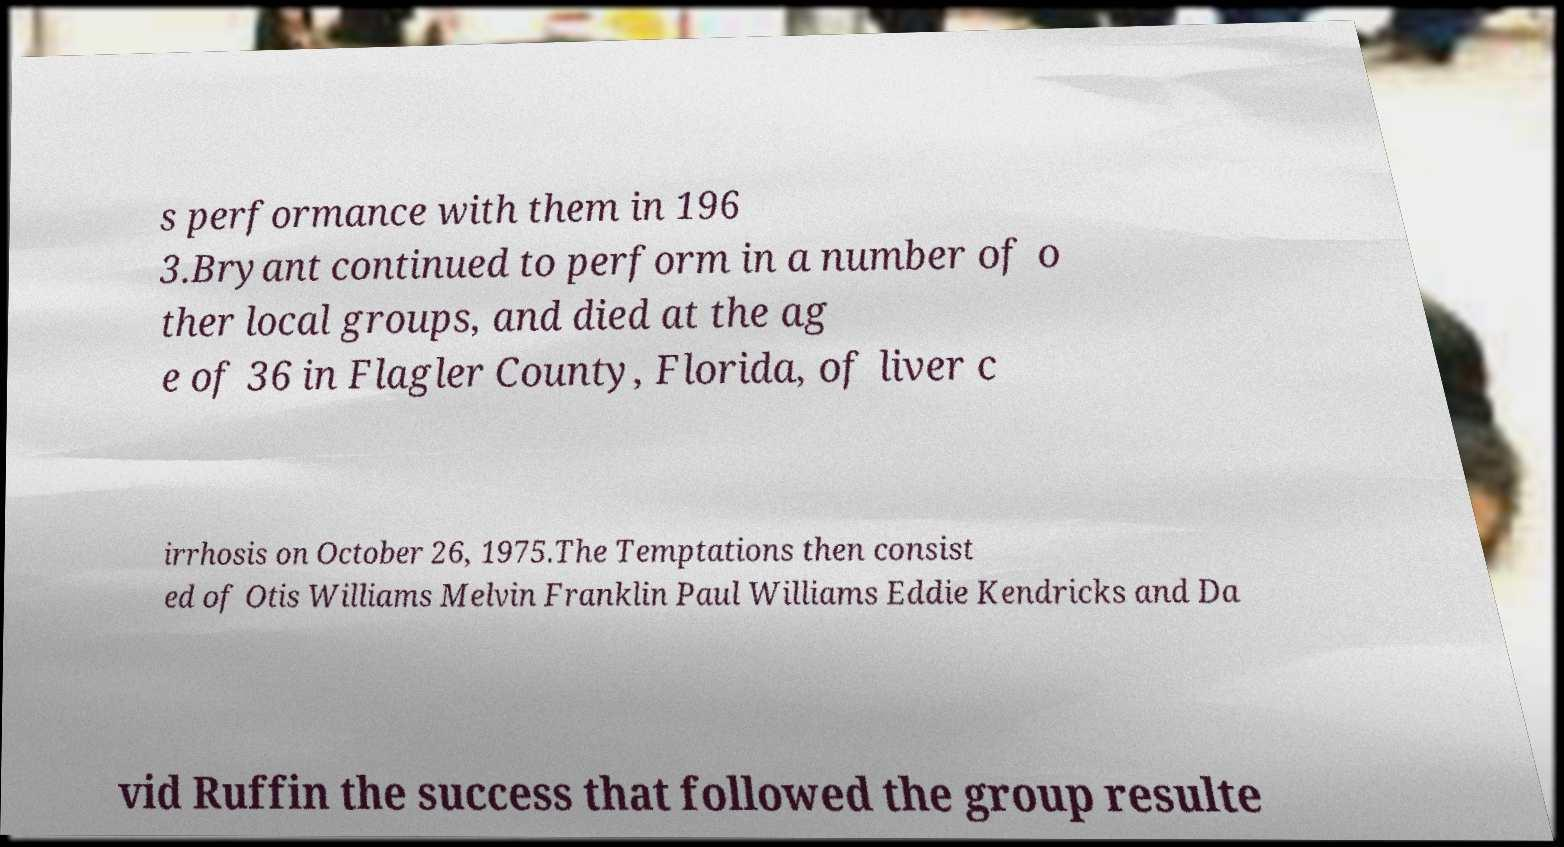Could you extract and type out the text from this image? s performance with them in 196 3.Bryant continued to perform in a number of o ther local groups, and died at the ag e of 36 in Flagler County, Florida, of liver c irrhosis on October 26, 1975.The Temptations then consist ed of Otis Williams Melvin Franklin Paul Williams Eddie Kendricks and Da vid Ruffin the success that followed the group resulte 